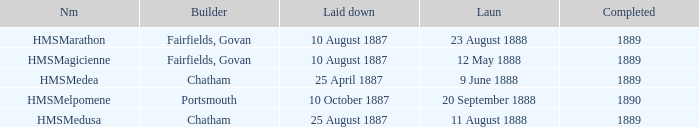Could you parse the entire table as a dict? {'header': ['Nm', 'Builder', 'Laid down', 'Laun', 'Completed'], 'rows': [['HMSMarathon', 'Fairfields, Govan', '10 August 1887', '23 August 1888', '1889'], ['HMSMagicienne', 'Fairfields, Govan', '10 August 1887', '12 May 1888', '1889'], ['HMSMedea', 'Chatham', '25 April 1887', '9 June 1888', '1889'], ['HMSMelpomene', 'Portsmouth', '10 October 1887', '20 September 1888', '1890'], ['HMSMedusa', 'Chatham', '25 August 1887', '11 August 1888', '1889']]} After 1889, which builder successfully completed a project? Portsmouth. 